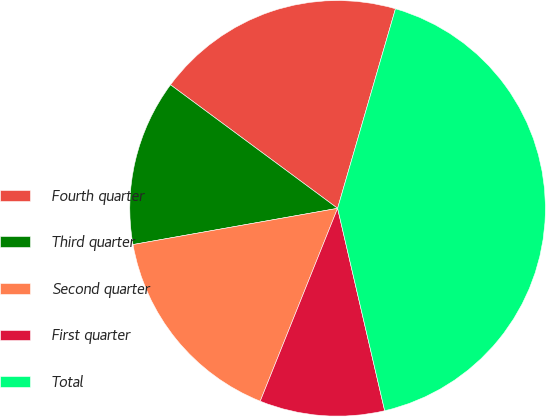<chart> <loc_0><loc_0><loc_500><loc_500><pie_chart><fcel>Fourth quarter<fcel>Third quarter<fcel>Second quarter<fcel>First quarter<fcel>Total<nl><fcel>19.36%<fcel>12.92%<fcel>16.14%<fcel>9.71%<fcel>41.87%<nl></chart> 